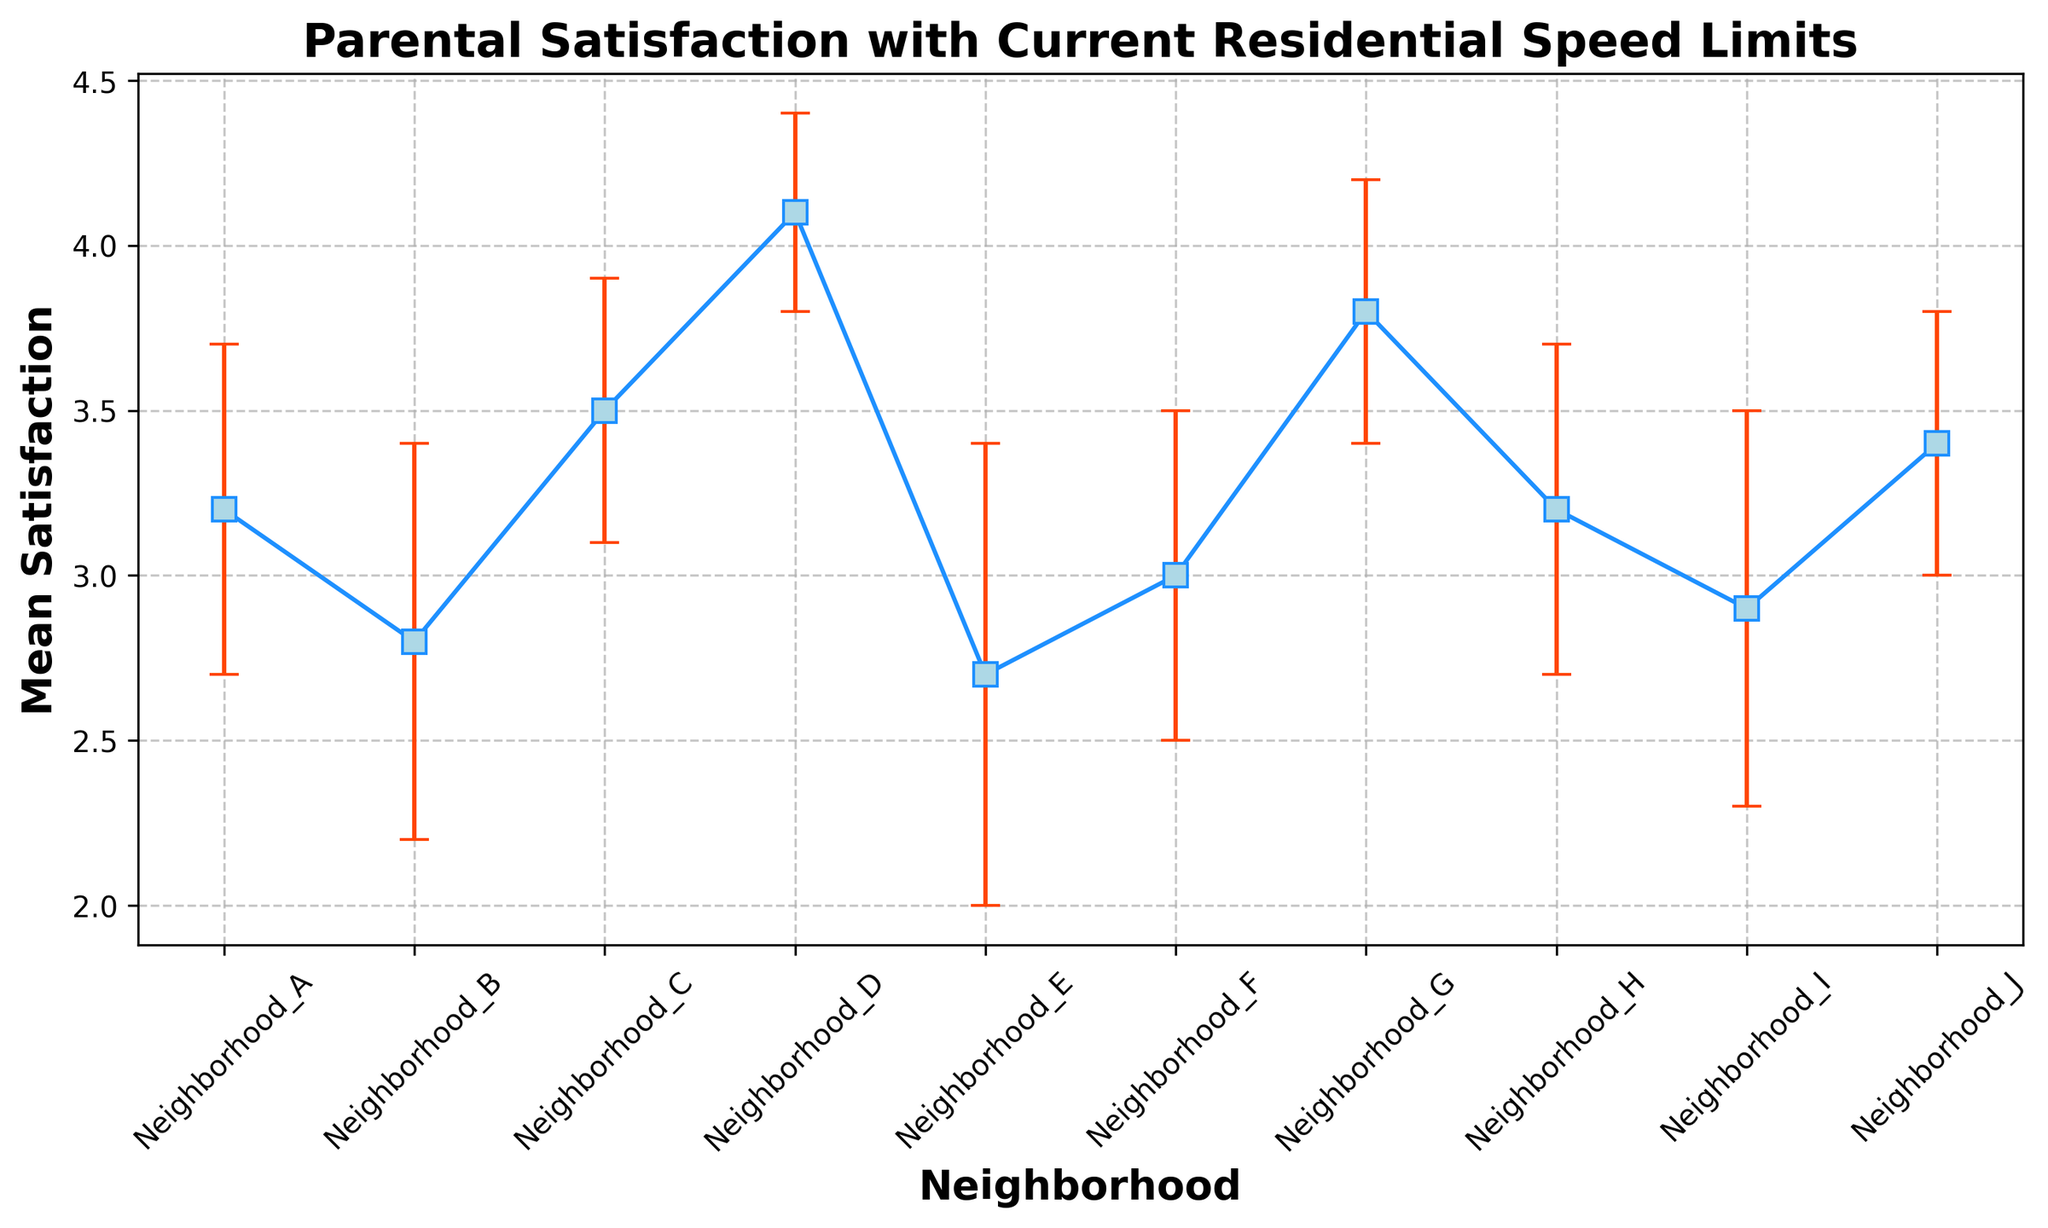Which neighborhood has the highest parental satisfaction with current residential speed limits? Look for the neighborhood with the highest mean satisfaction value. Neighborhood D has the highest mean satisfaction of 4.1.
Answer: Neighborhood D Which neighborhood has the lowest parental satisfaction with current residential speed limits? Look for the neighborhood with the lowest mean satisfaction value. Neighborhood E has the lowest mean satisfaction of 2.7.
Answer: Neighborhood E What is the difference in parental satisfaction between the highest and lowest scoring neighborhoods? Subtract the mean satisfaction of the lowest neighborhood (2.7) from the highest (4.1). The difference is 4.1 - 2.7.
Answer: 1.4 Which two neighborhoods have the same mean satisfaction score? Identify neighborhoods with matching mean satisfaction values. Neighborhoods A and H both have a mean satisfaction of 3.2.
Answer: Neighborhoods A and H Do any neighborhoods have overlapping confidence intervals that might suggest similar satisfaction levels? Examine the error bars to see if there are overlaps. The confidence intervals of Neighborhoods A, H, and F overlap, suggesting similar satisfaction levels.
Answer: Neighborhoods A, H, F What is the combined mean satisfaction of Neighborhoods B and I? Sum the mean satisfaction of Neighborhoods B (2.8) and I (2.9). The combined mean is 2.8 + 2.9.
Answer: 5.7 Which neighborhood has the highest uncertainty in its mean satisfaction score? Look for the neighborhood with the largest standard deviation (error bar length). Neighborhood E has the highest standard deviation of 0.7.
Answer: Neighborhood E Are there more neighborhoods with a mean satisfaction score above 3.0 or below 3.0? Count how many neighborhoods have mean satisfaction scores above and below 3.0. Six neighborhoods are above 3.0, and four are below 3.0.
Answer: Above 3.0 What is the average mean satisfaction score across all neighborhoods? Sum all mean satisfaction scores and divide by the number of neighborhoods (10). (3.2 + 2.8 + 3.5 + 4.1 + 2.7 + 3.0 + 3.8 + 3.2 + 2.9 + 3.4) / 10.
Answer: 3.26 Is there a trend in parental satisfaction levels across the neighborhoods as you move alphabetically from A to J? Compare the mean satisfaction scores from Neighborhood A to J to identify any obvious increasing or decreasing pattern. The satisfaction levels vary with no clear trend from A to J.
Answer: No clear trend 